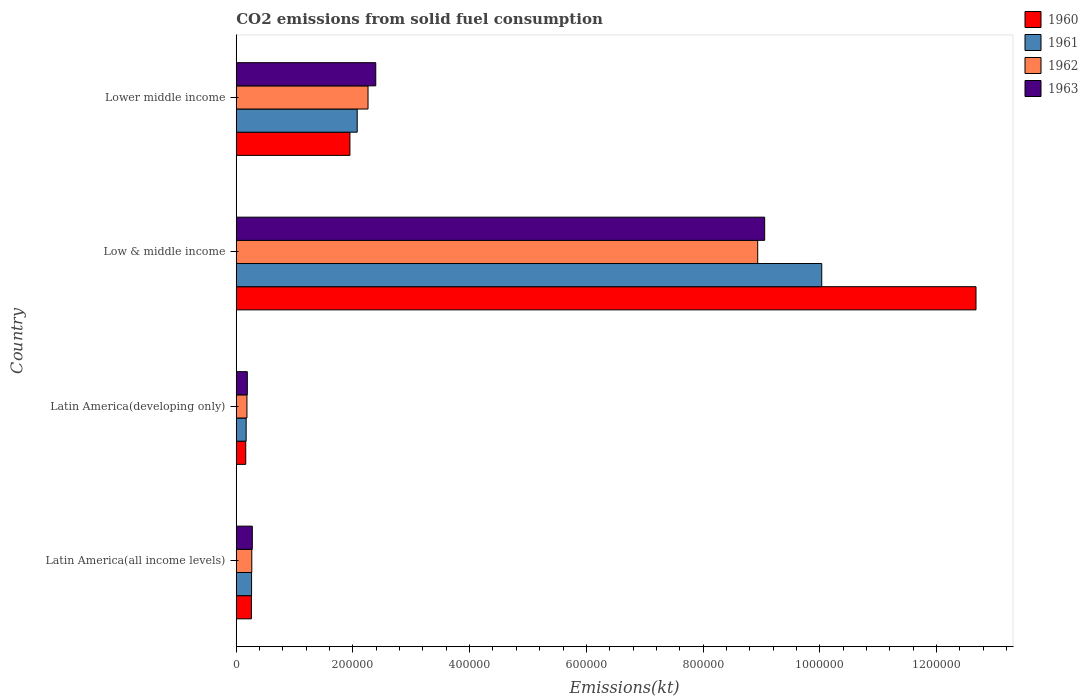How many groups of bars are there?
Give a very brief answer. 4. Are the number of bars per tick equal to the number of legend labels?
Your response must be concise. Yes. Are the number of bars on each tick of the Y-axis equal?
Offer a terse response. Yes. How many bars are there on the 1st tick from the top?
Provide a short and direct response. 4. How many bars are there on the 3rd tick from the bottom?
Your answer should be very brief. 4. What is the label of the 3rd group of bars from the top?
Your answer should be compact. Latin America(developing only). In how many cases, is the number of bars for a given country not equal to the number of legend labels?
Your answer should be very brief. 0. What is the amount of CO2 emitted in 1962 in Latin America(all income levels)?
Ensure brevity in your answer.  2.67e+04. Across all countries, what is the maximum amount of CO2 emitted in 1963?
Offer a very short reply. 9.06e+05. Across all countries, what is the minimum amount of CO2 emitted in 1960?
Offer a terse response. 1.62e+04. In which country was the amount of CO2 emitted in 1960 minimum?
Make the answer very short. Latin America(developing only). What is the total amount of CO2 emitted in 1962 in the graph?
Make the answer very short. 1.16e+06. What is the difference between the amount of CO2 emitted in 1962 in Low & middle income and that in Lower middle income?
Provide a short and direct response. 6.68e+05. What is the difference between the amount of CO2 emitted in 1960 in Latin America(all income levels) and the amount of CO2 emitted in 1962 in Low & middle income?
Provide a short and direct response. -8.68e+05. What is the average amount of CO2 emitted in 1960 per country?
Your answer should be compact. 3.76e+05. What is the difference between the amount of CO2 emitted in 1963 and amount of CO2 emitted in 1961 in Low & middle income?
Provide a short and direct response. -9.78e+04. What is the ratio of the amount of CO2 emitted in 1961 in Latin America(all income levels) to that in Low & middle income?
Provide a succinct answer. 0.03. Is the amount of CO2 emitted in 1960 in Latin America(all income levels) less than that in Lower middle income?
Provide a succinct answer. Yes. What is the difference between the highest and the second highest amount of CO2 emitted in 1962?
Ensure brevity in your answer.  6.68e+05. What is the difference between the highest and the lowest amount of CO2 emitted in 1962?
Provide a succinct answer. 8.75e+05. In how many countries, is the amount of CO2 emitted in 1961 greater than the average amount of CO2 emitted in 1961 taken over all countries?
Make the answer very short. 1. Is the sum of the amount of CO2 emitted in 1961 in Low & middle income and Lower middle income greater than the maximum amount of CO2 emitted in 1962 across all countries?
Your answer should be very brief. Yes. Is it the case that in every country, the sum of the amount of CO2 emitted in 1960 and amount of CO2 emitted in 1963 is greater than the sum of amount of CO2 emitted in 1962 and amount of CO2 emitted in 1961?
Provide a short and direct response. No. What does the 2nd bar from the top in Latin America(all income levels) represents?
Give a very brief answer. 1962. What does the 4th bar from the bottom in Latin America(developing only) represents?
Your response must be concise. 1963. Is it the case that in every country, the sum of the amount of CO2 emitted in 1962 and amount of CO2 emitted in 1961 is greater than the amount of CO2 emitted in 1963?
Provide a short and direct response. Yes. How many bars are there?
Provide a succinct answer. 16. Are all the bars in the graph horizontal?
Offer a very short reply. Yes. How many countries are there in the graph?
Make the answer very short. 4. What is the difference between two consecutive major ticks on the X-axis?
Provide a succinct answer. 2.00e+05. Are the values on the major ticks of X-axis written in scientific E-notation?
Ensure brevity in your answer.  No. Does the graph contain grids?
Provide a short and direct response. No. Where does the legend appear in the graph?
Provide a succinct answer. Top right. How are the legend labels stacked?
Make the answer very short. Vertical. What is the title of the graph?
Offer a very short reply. CO2 emissions from solid fuel consumption. What is the label or title of the X-axis?
Offer a terse response. Emissions(kt). What is the Emissions(kt) of 1960 in Latin America(all income levels)?
Offer a terse response. 2.60e+04. What is the Emissions(kt) of 1961 in Latin America(all income levels)?
Your answer should be very brief. 2.63e+04. What is the Emissions(kt) of 1962 in Latin America(all income levels)?
Give a very brief answer. 2.67e+04. What is the Emissions(kt) of 1963 in Latin America(all income levels)?
Offer a very short reply. 2.75e+04. What is the Emissions(kt) of 1960 in Latin America(developing only)?
Your answer should be compact. 1.62e+04. What is the Emissions(kt) of 1961 in Latin America(developing only)?
Offer a very short reply. 1.70e+04. What is the Emissions(kt) in 1962 in Latin America(developing only)?
Provide a short and direct response. 1.83e+04. What is the Emissions(kt) in 1963 in Latin America(developing only)?
Offer a terse response. 1.90e+04. What is the Emissions(kt) in 1960 in Low & middle income?
Provide a succinct answer. 1.27e+06. What is the Emissions(kt) in 1961 in Low & middle income?
Make the answer very short. 1.00e+06. What is the Emissions(kt) in 1962 in Low & middle income?
Make the answer very short. 8.94e+05. What is the Emissions(kt) in 1963 in Low & middle income?
Keep it short and to the point. 9.06e+05. What is the Emissions(kt) of 1960 in Lower middle income?
Offer a terse response. 1.95e+05. What is the Emissions(kt) in 1961 in Lower middle income?
Your response must be concise. 2.07e+05. What is the Emissions(kt) in 1962 in Lower middle income?
Offer a very short reply. 2.26e+05. What is the Emissions(kt) in 1963 in Lower middle income?
Keep it short and to the point. 2.39e+05. Across all countries, what is the maximum Emissions(kt) in 1960?
Offer a very short reply. 1.27e+06. Across all countries, what is the maximum Emissions(kt) in 1961?
Offer a very short reply. 1.00e+06. Across all countries, what is the maximum Emissions(kt) of 1962?
Ensure brevity in your answer.  8.94e+05. Across all countries, what is the maximum Emissions(kt) in 1963?
Your response must be concise. 9.06e+05. Across all countries, what is the minimum Emissions(kt) of 1960?
Provide a short and direct response. 1.62e+04. Across all countries, what is the minimum Emissions(kt) in 1961?
Offer a terse response. 1.70e+04. Across all countries, what is the minimum Emissions(kt) of 1962?
Provide a short and direct response. 1.83e+04. Across all countries, what is the minimum Emissions(kt) in 1963?
Your answer should be very brief. 1.90e+04. What is the total Emissions(kt) of 1960 in the graph?
Offer a very short reply. 1.50e+06. What is the total Emissions(kt) in 1961 in the graph?
Your answer should be very brief. 1.25e+06. What is the total Emissions(kt) in 1962 in the graph?
Offer a very short reply. 1.16e+06. What is the total Emissions(kt) of 1963 in the graph?
Your answer should be compact. 1.19e+06. What is the difference between the Emissions(kt) in 1960 in Latin America(all income levels) and that in Latin America(developing only)?
Your answer should be very brief. 9759.8. What is the difference between the Emissions(kt) of 1961 in Latin America(all income levels) and that in Latin America(developing only)?
Provide a succinct answer. 9282.45. What is the difference between the Emissions(kt) in 1962 in Latin America(all income levels) and that in Latin America(developing only)?
Offer a terse response. 8301.83. What is the difference between the Emissions(kt) of 1963 in Latin America(all income levels) and that in Latin America(developing only)?
Your answer should be compact. 8542.91. What is the difference between the Emissions(kt) in 1960 in Latin America(all income levels) and that in Low & middle income?
Your answer should be compact. -1.24e+06. What is the difference between the Emissions(kt) of 1961 in Latin America(all income levels) and that in Low & middle income?
Provide a succinct answer. -9.77e+05. What is the difference between the Emissions(kt) in 1962 in Latin America(all income levels) and that in Low & middle income?
Keep it short and to the point. -8.67e+05. What is the difference between the Emissions(kt) of 1963 in Latin America(all income levels) and that in Low & middle income?
Make the answer very short. -8.78e+05. What is the difference between the Emissions(kt) of 1960 in Latin America(all income levels) and that in Lower middle income?
Offer a very short reply. -1.69e+05. What is the difference between the Emissions(kt) of 1961 in Latin America(all income levels) and that in Lower middle income?
Your answer should be very brief. -1.81e+05. What is the difference between the Emissions(kt) in 1962 in Latin America(all income levels) and that in Lower middle income?
Give a very brief answer. -1.99e+05. What is the difference between the Emissions(kt) of 1963 in Latin America(all income levels) and that in Lower middle income?
Keep it short and to the point. -2.12e+05. What is the difference between the Emissions(kt) of 1960 in Latin America(developing only) and that in Low & middle income?
Your answer should be compact. -1.25e+06. What is the difference between the Emissions(kt) of 1961 in Latin America(developing only) and that in Low & middle income?
Offer a terse response. -9.86e+05. What is the difference between the Emissions(kt) of 1962 in Latin America(developing only) and that in Low & middle income?
Your answer should be compact. -8.75e+05. What is the difference between the Emissions(kt) of 1963 in Latin America(developing only) and that in Low & middle income?
Your answer should be compact. -8.87e+05. What is the difference between the Emissions(kt) in 1960 in Latin America(developing only) and that in Lower middle income?
Provide a succinct answer. -1.79e+05. What is the difference between the Emissions(kt) in 1961 in Latin America(developing only) and that in Lower middle income?
Provide a succinct answer. -1.90e+05. What is the difference between the Emissions(kt) of 1962 in Latin America(developing only) and that in Lower middle income?
Your answer should be very brief. -2.08e+05. What is the difference between the Emissions(kt) of 1963 in Latin America(developing only) and that in Lower middle income?
Offer a very short reply. -2.20e+05. What is the difference between the Emissions(kt) of 1960 in Low & middle income and that in Lower middle income?
Provide a short and direct response. 1.07e+06. What is the difference between the Emissions(kt) in 1961 in Low & middle income and that in Lower middle income?
Offer a very short reply. 7.96e+05. What is the difference between the Emissions(kt) in 1962 in Low & middle income and that in Lower middle income?
Make the answer very short. 6.68e+05. What is the difference between the Emissions(kt) of 1963 in Low & middle income and that in Lower middle income?
Keep it short and to the point. 6.67e+05. What is the difference between the Emissions(kt) of 1960 in Latin America(all income levels) and the Emissions(kt) of 1961 in Latin America(developing only)?
Make the answer very short. 9031.46. What is the difference between the Emissions(kt) in 1960 in Latin America(all income levels) and the Emissions(kt) in 1962 in Latin America(developing only)?
Offer a terse response. 7658.68. What is the difference between the Emissions(kt) of 1960 in Latin America(all income levels) and the Emissions(kt) of 1963 in Latin America(developing only)?
Provide a short and direct response. 7040.93. What is the difference between the Emissions(kt) in 1961 in Latin America(all income levels) and the Emissions(kt) in 1962 in Latin America(developing only)?
Offer a very short reply. 7909.66. What is the difference between the Emissions(kt) of 1961 in Latin America(all income levels) and the Emissions(kt) of 1963 in Latin America(developing only)?
Your response must be concise. 7291.91. What is the difference between the Emissions(kt) in 1962 in Latin America(all income levels) and the Emissions(kt) in 1963 in Latin America(developing only)?
Your answer should be compact. 7684.07. What is the difference between the Emissions(kt) in 1960 in Latin America(all income levels) and the Emissions(kt) in 1961 in Low & middle income?
Your answer should be compact. -9.77e+05. What is the difference between the Emissions(kt) of 1960 in Latin America(all income levels) and the Emissions(kt) of 1962 in Low & middle income?
Your response must be concise. -8.68e+05. What is the difference between the Emissions(kt) in 1960 in Latin America(all income levels) and the Emissions(kt) in 1963 in Low & middle income?
Offer a terse response. -8.80e+05. What is the difference between the Emissions(kt) of 1961 in Latin America(all income levels) and the Emissions(kt) of 1962 in Low & middle income?
Make the answer very short. -8.67e+05. What is the difference between the Emissions(kt) in 1961 in Latin America(all income levels) and the Emissions(kt) in 1963 in Low & middle income?
Ensure brevity in your answer.  -8.79e+05. What is the difference between the Emissions(kt) in 1962 in Latin America(all income levels) and the Emissions(kt) in 1963 in Low & middle income?
Provide a succinct answer. -8.79e+05. What is the difference between the Emissions(kt) in 1960 in Latin America(all income levels) and the Emissions(kt) in 1961 in Lower middle income?
Give a very brief answer. -1.81e+05. What is the difference between the Emissions(kt) in 1960 in Latin America(all income levels) and the Emissions(kt) in 1962 in Lower middle income?
Offer a terse response. -2.00e+05. What is the difference between the Emissions(kt) of 1960 in Latin America(all income levels) and the Emissions(kt) of 1963 in Lower middle income?
Make the answer very short. -2.13e+05. What is the difference between the Emissions(kt) in 1961 in Latin America(all income levels) and the Emissions(kt) in 1962 in Lower middle income?
Keep it short and to the point. -2.00e+05. What is the difference between the Emissions(kt) in 1961 in Latin America(all income levels) and the Emissions(kt) in 1963 in Lower middle income?
Offer a terse response. -2.13e+05. What is the difference between the Emissions(kt) of 1962 in Latin America(all income levels) and the Emissions(kt) of 1963 in Lower middle income?
Make the answer very short. -2.12e+05. What is the difference between the Emissions(kt) in 1960 in Latin America(developing only) and the Emissions(kt) in 1961 in Low & middle income?
Provide a succinct answer. -9.87e+05. What is the difference between the Emissions(kt) of 1960 in Latin America(developing only) and the Emissions(kt) of 1962 in Low & middle income?
Provide a short and direct response. -8.77e+05. What is the difference between the Emissions(kt) of 1960 in Latin America(developing only) and the Emissions(kt) of 1963 in Low & middle income?
Offer a very short reply. -8.89e+05. What is the difference between the Emissions(kt) of 1961 in Latin America(developing only) and the Emissions(kt) of 1962 in Low & middle income?
Keep it short and to the point. -8.77e+05. What is the difference between the Emissions(kt) of 1961 in Latin America(developing only) and the Emissions(kt) of 1963 in Low & middle income?
Make the answer very short. -8.89e+05. What is the difference between the Emissions(kt) in 1962 in Latin America(developing only) and the Emissions(kt) in 1963 in Low & middle income?
Give a very brief answer. -8.87e+05. What is the difference between the Emissions(kt) in 1960 in Latin America(developing only) and the Emissions(kt) in 1961 in Lower middle income?
Offer a terse response. -1.91e+05. What is the difference between the Emissions(kt) of 1960 in Latin America(developing only) and the Emissions(kt) of 1962 in Lower middle income?
Keep it short and to the point. -2.10e+05. What is the difference between the Emissions(kt) of 1960 in Latin America(developing only) and the Emissions(kt) of 1963 in Lower middle income?
Provide a short and direct response. -2.23e+05. What is the difference between the Emissions(kt) in 1961 in Latin America(developing only) and the Emissions(kt) in 1962 in Lower middle income?
Make the answer very short. -2.09e+05. What is the difference between the Emissions(kt) in 1961 in Latin America(developing only) and the Emissions(kt) in 1963 in Lower middle income?
Offer a very short reply. -2.22e+05. What is the difference between the Emissions(kt) of 1962 in Latin America(developing only) and the Emissions(kt) of 1963 in Lower middle income?
Provide a succinct answer. -2.21e+05. What is the difference between the Emissions(kt) in 1960 in Low & middle income and the Emissions(kt) in 1961 in Lower middle income?
Offer a very short reply. 1.06e+06. What is the difference between the Emissions(kt) in 1960 in Low & middle income and the Emissions(kt) in 1962 in Lower middle income?
Your answer should be compact. 1.04e+06. What is the difference between the Emissions(kt) of 1960 in Low & middle income and the Emissions(kt) of 1963 in Lower middle income?
Make the answer very short. 1.03e+06. What is the difference between the Emissions(kt) of 1961 in Low & middle income and the Emissions(kt) of 1962 in Lower middle income?
Offer a terse response. 7.78e+05. What is the difference between the Emissions(kt) in 1961 in Low & middle income and the Emissions(kt) in 1963 in Lower middle income?
Give a very brief answer. 7.64e+05. What is the difference between the Emissions(kt) in 1962 in Low & middle income and the Emissions(kt) in 1963 in Lower middle income?
Your answer should be compact. 6.55e+05. What is the average Emissions(kt) in 1960 per country?
Provide a short and direct response. 3.76e+05. What is the average Emissions(kt) of 1961 per country?
Provide a succinct answer. 3.13e+05. What is the average Emissions(kt) in 1962 per country?
Make the answer very short. 2.91e+05. What is the average Emissions(kt) in 1963 per country?
Keep it short and to the point. 2.98e+05. What is the difference between the Emissions(kt) of 1960 and Emissions(kt) of 1961 in Latin America(all income levels)?
Provide a succinct answer. -250.98. What is the difference between the Emissions(kt) of 1960 and Emissions(kt) of 1962 in Latin America(all income levels)?
Keep it short and to the point. -643.15. What is the difference between the Emissions(kt) of 1960 and Emissions(kt) of 1963 in Latin America(all income levels)?
Your response must be concise. -1501.98. What is the difference between the Emissions(kt) in 1961 and Emissions(kt) in 1962 in Latin America(all income levels)?
Provide a short and direct response. -392.16. What is the difference between the Emissions(kt) of 1961 and Emissions(kt) of 1963 in Latin America(all income levels)?
Give a very brief answer. -1251. What is the difference between the Emissions(kt) of 1962 and Emissions(kt) of 1963 in Latin America(all income levels)?
Give a very brief answer. -858.84. What is the difference between the Emissions(kt) of 1960 and Emissions(kt) of 1961 in Latin America(developing only)?
Make the answer very short. -728.34. What is the difference between the Emissions(kt) of 1960 and Emissions(kt) of 1962 in Latin America(developing only)?
Your answer should be very brief. -2101.12. What is the difference between the Emissions(kt) of 1960 and Emissions(kt) of 1963 in Latin America(developing only)?
Provide a short and direct response. -2718.88. What is the difference between the Emissions(kt) in 1961 and Emissions(kt) in 1962 in Latin America(developing only)?
Your response must be concise. -1372.79. What is the difference between the Emissions(kt) in 1961 and Emissions(kt) in 1963 in Latin America(developing only)?
Offer a very short reply. -1990.54. What is the difference between the Emissions(kt) in 1962 and Emissions(kt) in 1963 in Latin America(developing only)?
Your answer should be compact. -617.75. What is the difference between the Emissions(kt) of 1960 and Emissions(kt) of 1961 in Low & middle income?
Make the answer very short. 2.64e+05. What is the difference between the Emissions(kt) of 1960 and Emissions(kt) of 1962 in Low & middle income?
Your response must be concise. 3.74e+05. What is the difference between the Emissions(kt) of 1960 and Emissions(kt) of 1963 in Low & middle income?
Your answer should be very brief. 3.62e+05. What is the difference between the Emissions(kt) in 1961 and Emissions(kt) in 1962 in Low & middle income?
Offer a terse response. 1.10e+05. What is the difference between the Emissions(kt) in 1961 and Emissions(kt) in 1963 in Low & middle income?
Offer a very short reply. 9.78e+04. What is the difference between the Emissions(kt) in 1962 and Emissions(kt) in 1963 in Low & middle income?
Your answer should be very brief. -1.20e+04. What is the difference between the Emissions(kt) of 1960 and Emissions(kt) of 1961 in Lower middle income?
Your response must be concise. -1.25e+04. What is the difference between the Emissions(kt) of 1960 and Emissions(kt) of 1962 in Lower middle income?
Offer a very short reply. -3.10e+04. What is the difference between the Emissions(kt) of 1960 and Emissions(kt) of 1963 in Lower middle income?
Your answer should be compact. -4.43e+04. What is the difference between the Emissions(kt) of 1961 and Emissions(kt) of 1962 in Lower middle income?
Give a very brief answer. -1.86e+04. What is the difference between the Emissions(kt) of 1961 and Emissions(kt) of 1963 in Lower middle income?
Your response must be concise. -3.18e+04. What is the difference between the Emissions(kt) in 1962 and Emissions(kt) in 1963 in Lower middle income?
Give a very brief answer. -1.32e+04. What is the ratio of the Emissions(kt) of 1960 in Latin America(all income levels) to that in Latin America(developing only)?
Your answer should be very brief. 1.6. What is the ratio of the Emissions(kt) of 1961 in Latin America(all income levels) to that in Latin America(developing only)?
Provide a short and direct response. 1.55. What is the ratio of the Emissions(kt) of 1962 in Latin America(all income levels) to that in Latin America(developing only)?
Your answer should be compact. 1.45. What is the ratio of the Emissions(kt) of 1963 in Latin America(all income levels) to that in Latin America(developing only)?
Offer a terse response. 1.45. What is the ratio of the Emissions(kt) in 1960 in Latin America(all income levels) to that in Low & middle income?
Your response must be concise. 0.02. What is the ratio of the Emissions(kt) in 1961 in Latin America(all income levels) to that in Low & middle income?
Offer a very short reply. 0.03. What is the ratio of the Emissions(kt) in 1962 in Latin America(all income levels) to that in Low & middle income?
Provide a short and direct response. 0.03. What is the ratio of the Emissions(kt) in 1963 in Latin America(all income levels) to that in Low & middle income?
Offer a terse response. 0.03. What is the ratio of the Emissions(kt) in 1960 in Latin America(all income levels) to that in Lower middle income?
Ensure brevity in your answer.  0.13. What is the ratio of the Emissions(kt) of 1961 in Latin America(all income levels) to that in Lower middle income?
Offer a terse response. 0.13. What is the ratio of the Emissions(kt) in 1962 in Latin America(all income levels) to that in Lower middle income?
Provide a succinct answer. 0.12. What is the ratio of the Emissions(kt) of 1963 in Latin America(all income levels) to that in Lower middle income?
Keep it short and to the point. 0.12. What is the ratio of the Emissions(kt) of 1960 in Latin America(developing only) to that in Low & middle income?
Offer a terse response. 0.01. What is the ratio of the Emissions(kt) of 1961 in Latin America(developing only) to that in Low & middle income?
Offer a very short reply. 0.02. What is the ratio of the Emissions(kt) in 1962 in Latin America(developing only) to that in Low & middle income?
Make the answer very short. 0.02. What is the ratio of the Emissions(kt) in 1963 in Latin America(developing only) to that in Low & middle income?
Provide a short and direct response. 0.02. What is the ratio of the Emissions(kt) of 1960 in Latin America(developing only) to that in Lower middle income?
Your answer should be compact. 0.08. What is the ratio of the Emissions(kt) of 1961 in Latin America(developing only) to that in Lower middle income?
Give a very brief answer. 0.08. What is the ratio of the Emissions(kt) in 1962 in Latin America(developing only) to that in Lower middle income?
Give a very brief answer. 0.08. What is the ratio of the Emissions(kt) of 1963 in Latin America(developing only) to that in Lower middle income?
Ensure brevity in your answer.  0.08. What is the ratio of the Emissions(kt) in 1960 in Low & middle income to that in Lower middle income?
Your response must be concise. 6.51. What is the ratio of the Emissions(kt) in 1961 in Low & middle income to that in Lower middle income?
Offer a very short reply. 4.84. What is the ratio of the Emissions(kt) of 1962 in Low & middle income to that in Lower middle income?
Your answer should be compact. 3.96. What is the ratio of the Emissions(kt) of 1963 in Low & middle income to that in Lower middle income?
Offer a very short reply. 3.79. What is the difference between the highest and the second highest Emissions(kt) in 1960?
Ensure brevity in your answer.  1.07e+06. What is the difference between the highest and the second highest Emissions(kt) in 1961?
Ensure brevity in your answer.  7.96e+05. What is the difference between the highest and the second highest Emissions(kt) of 1962?
Give a very brief answer. 6.68e+05. What is the difference between the highest and the second highest Emissions(kt) of 1963?
Your answer should be compact. 6.67e+05. What is the difference between the highest and the lowest Emissions(kt) in 1960?
Your answer should be compact. 1.25e+06. What is the difference between the highest and the lowest Emissions(kt) of 1961?
Keep it short and to the point. 9.86e+05. What is the difference between the highest and the lowest Emissions(kt) of 1962?
Make the answer very short. 8.75e+05. What is the difference between the highest and the lowest Emissions(kt) of 1963?
Ensure brevity in your answer.  8.87e+05. 